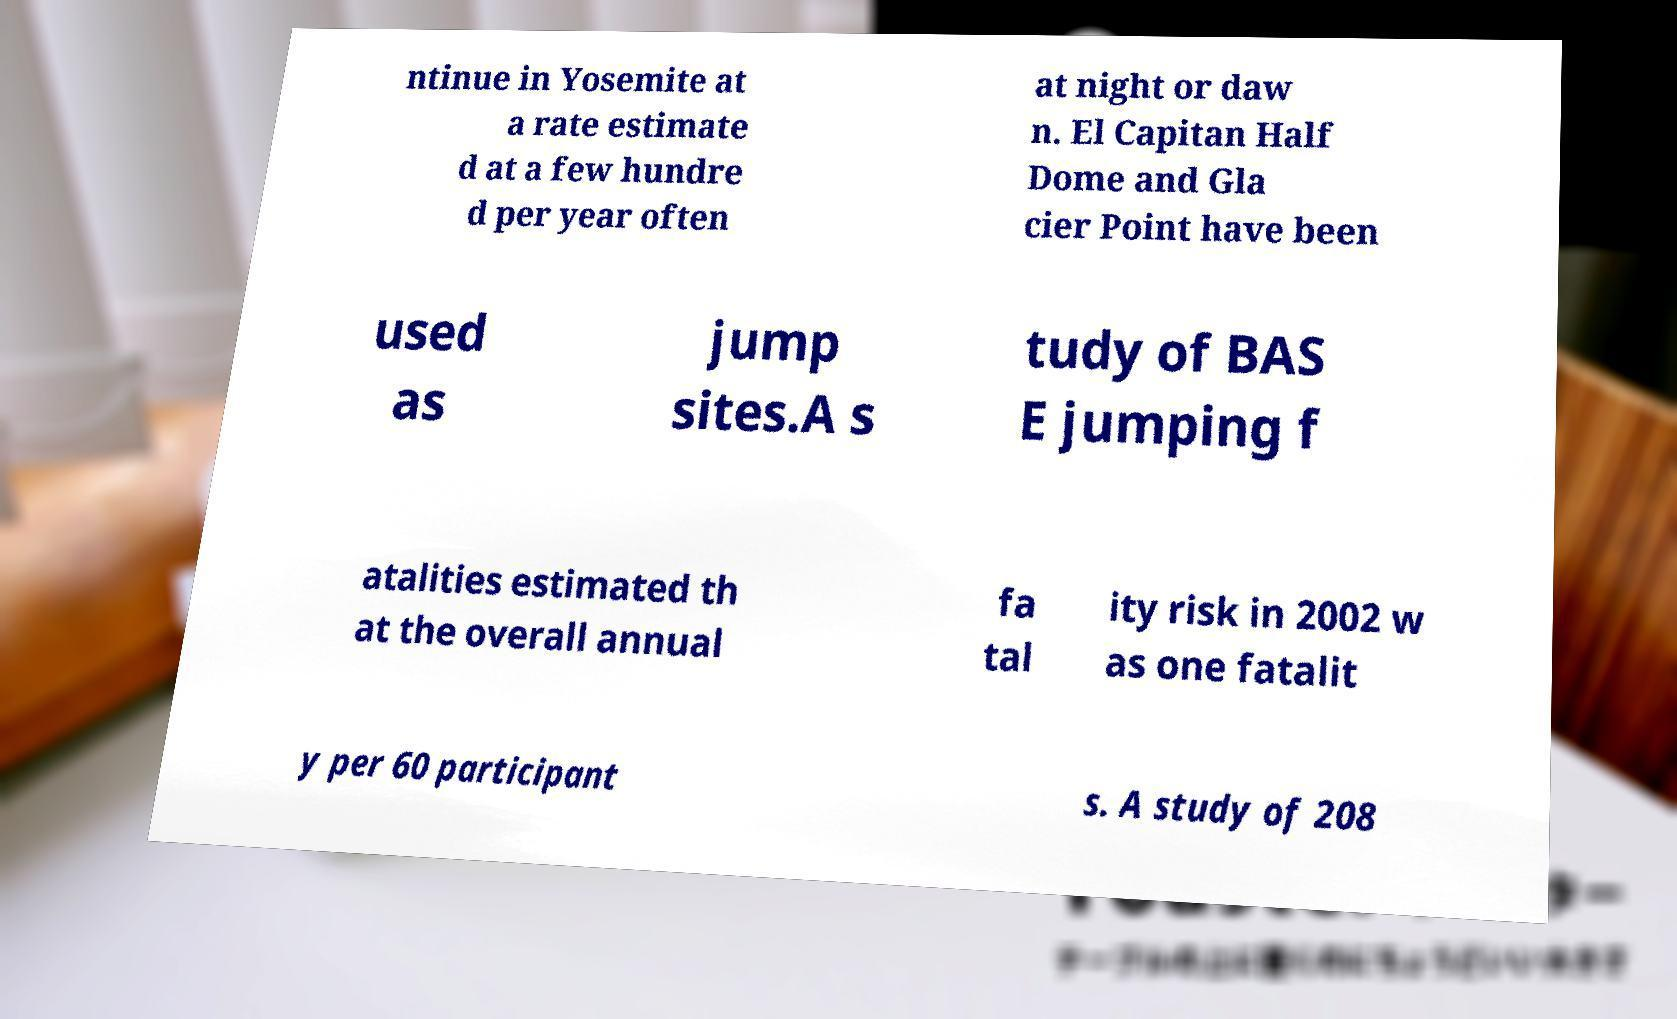Could you extract and type out the text from this image? ntinue in Yosemite at a rate estimate d at a few hundre d per year often at night or daw n. El Capitan Half Dome and Gla cier Point have been used as jump sites.A s tudy of BAS E jumping f atalities estimated th at the overall annual fa tal ity risk in 2002 w as one fatalit y per 60 participant s. A study of 208 